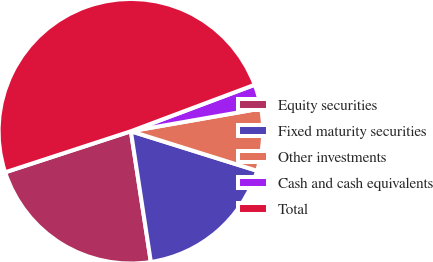Convert chart. <chart><loc_0><loc_0><loc_500><loc_500><pie_chart><fcel>Equity securities<fcel>Fixed maturity securities<fcel>Other investments<fcel>Cash and cash equivalents<fcel>Total<nl><fcel>22.39%<fcel>17.75%<fcel>7.59%<fcel>2.96%<fcel>49.31%<nl></chart> 